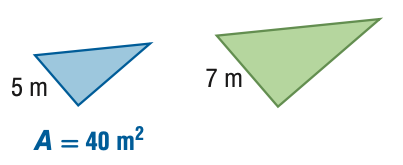Answer the mathemtical geometry problem and directly provide the correct option letter.
Question: For the pair of similar figures, find the area of the green figure.
Choices: A: 20.4 B: 28.6 C: 56.0 D: 78.4 D 